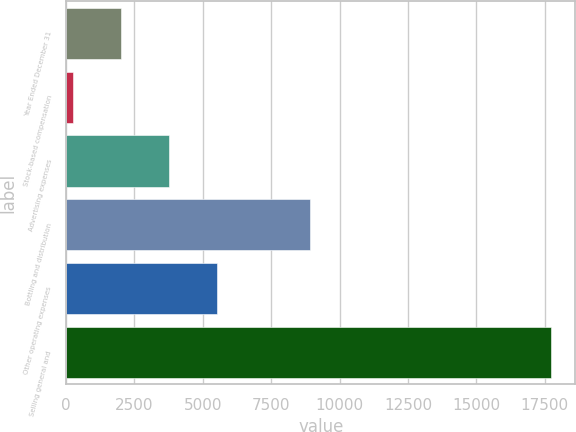<chart> <loc_0><loc_0><loc_500><loc_500><bar_chart><fcel>Year Ended December 31<fcel>Stock-based compensation<fcel>Advertising expenses<fcel>Bottling and distribution<fcel>Other operating expenses<fcel>Selling general and<nl><fcel>2012<fcel>259<fcel>3759.9<fcel>8905<fcel>5507.8<fcel>17738<nl></chart> 